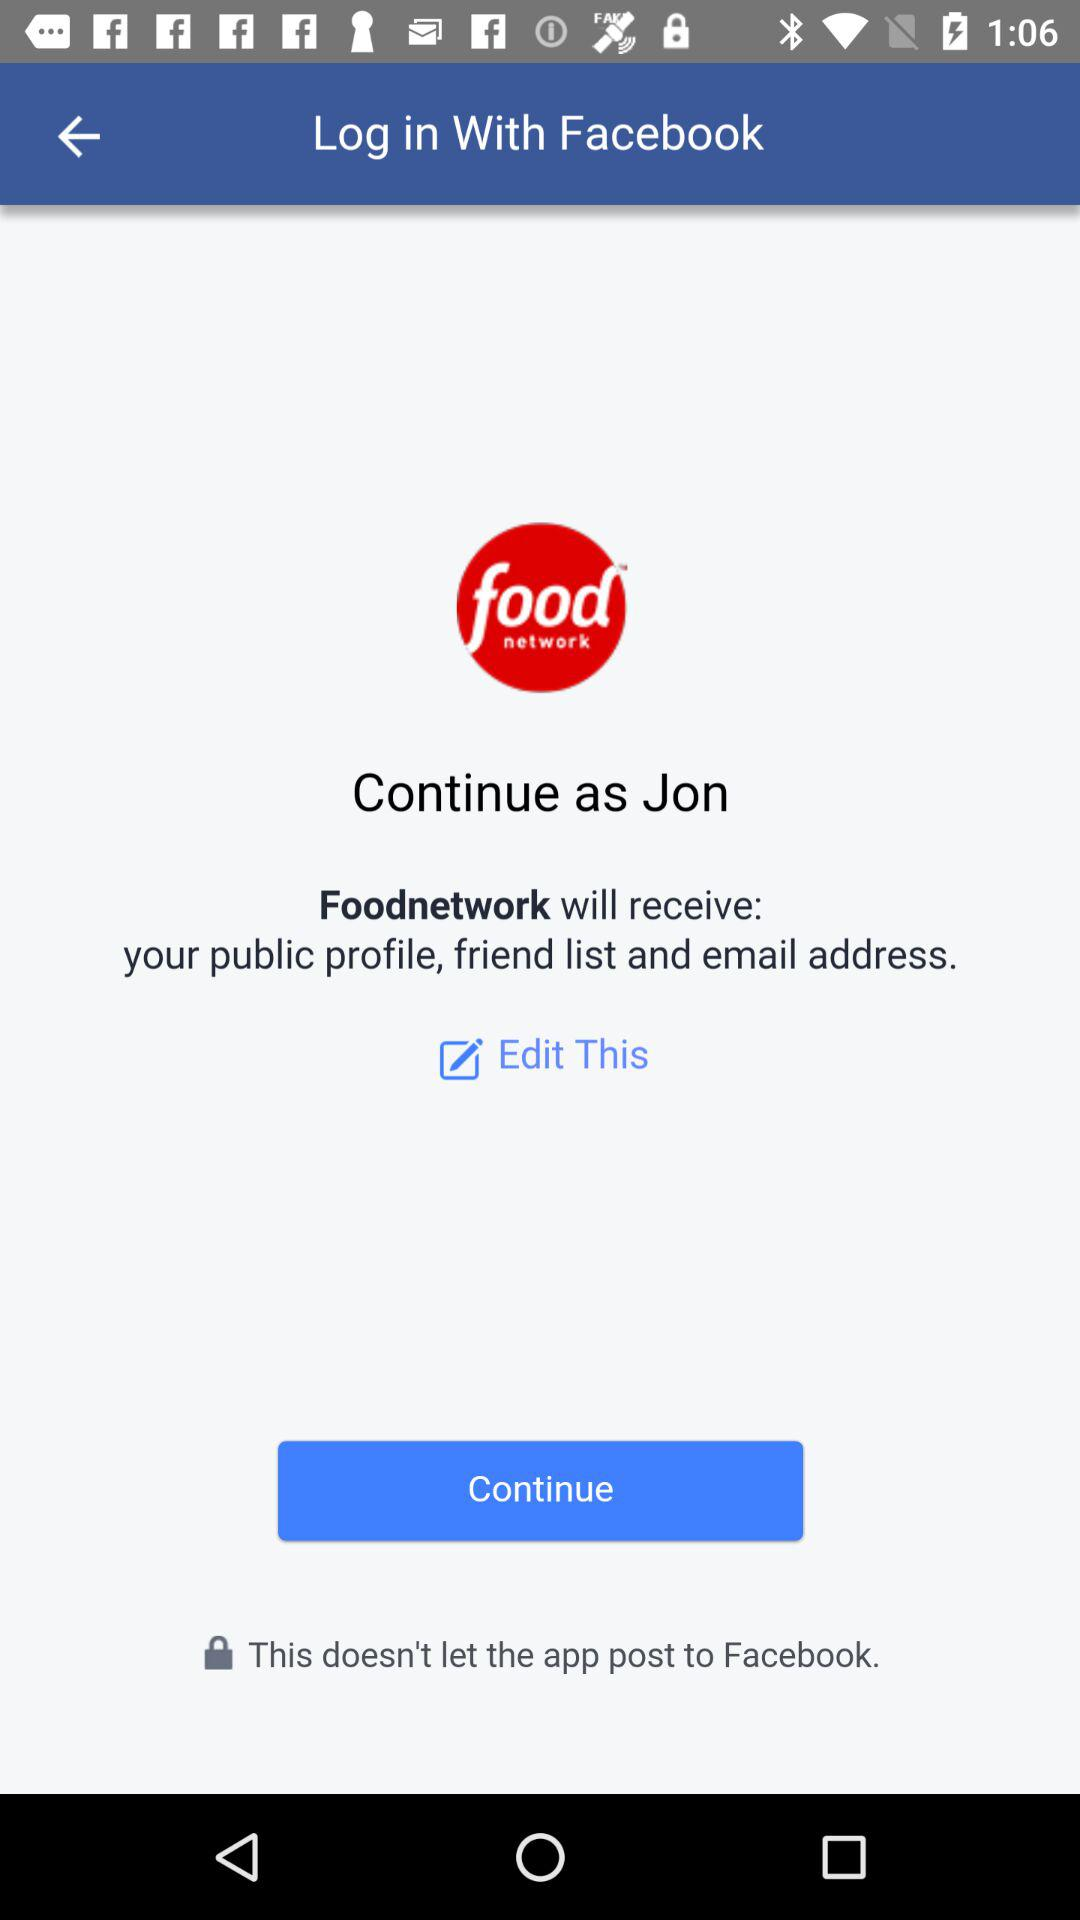How many profile details will Foodnetwork receive?
Answer the question using a single word or phrase. 3 